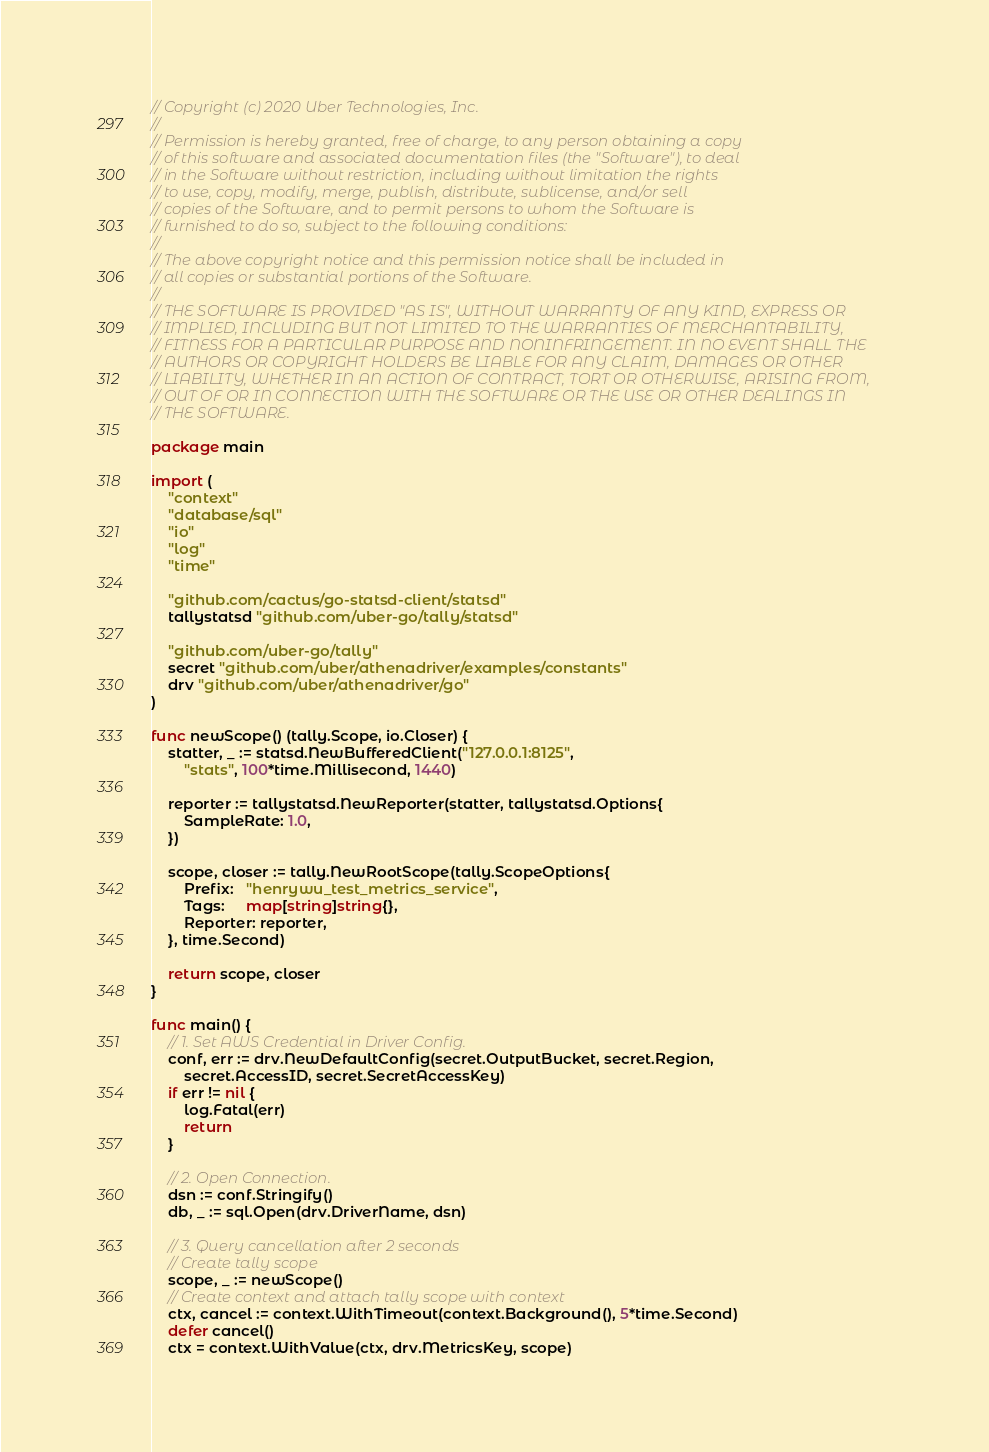<code> <loc_0><loc_0><loc_500><loc_500><_Go_>// Copyright (c) 2020 Uber Technologies, Inc.
//
// Permission is hereby granted, free of charge, to any person obtaining a copy
// of this software and associated documentation files (the "Software"), to deal
// in the Software without restriction, including without limitation the rights
// to use, copy, modify, merge, publish, distribute, sublicense, and/or sell
// copies of the Software, and to permit persons to whom the Software is
// furnished to do so, subject to the following conditions:
//
// The above copyright notice and this permission notice shall be included in
// all copies or substantial portions of the Software.
//
// THE SOFTWARE IS PROVIDED "AS IS", WITHOUT WARRANTY OF ANY KIND, EXPRESS OR
// IMPLIED, INCLUDING BUT NOT LIMITED TO THE WARRANTIES OF MERCHANTABILITY,
// FITNESS FOR A PARTICULAR PURPOSE AND NONINFRINGEMENT. IN NO EVENT SHALL THE
// AUTHORS OR COPYRIGHT HOLDERS BE LIABLE FOR ANY CLAIM, DAMAGES OR OTHER
// LIABILITY, WHETHER IN AN ACTION OF CONTRACT, TORT OR OTHERWISE, ARISING FROM,
// OUT OF OR IN CONNECTION WITH THE SOFTWARE OR THE USE OR OTHER DEALINGS IN
// THE SOFTWARE.

package main

import (
	"context"
	"database/sql"
	"io"
	"log"
	"time"

	"github.com/cactus/go-statsd-client/statsd"
	tallystatsd "github.com/uber-go/tally/statsd"

	"github.com/uber-go/tally"
	secret "github.com/uber/athenadriver/examples/constants"
	drv "github.com/uber/athenadriver/go"
)

func newScope() (tally.Scope, io.Closer) {
	statter, _ := statsd.NewBufferedClient("127.0.0.1:8125",
		"stats", 100*time.Millisecond, 1440)

	reporter := tallystatsd.NewReporter(statter, tallystatsd.Options{
		SampleRate: 1.0,
	})

	scope, closer := tally.NewRootScope(tally.ScopeOptions{
		Prefix:   "henrywu_test_metrics_service",
		Tags:     map[string]string{},
		Reporter: reporter,
	}, time.Second)

	return scope, closer
}

func main() {
	// 1. Set AWS Credential in Driver Config.
	conf, err := drv.NewDefaultConfig(secret.OutputBucket, secret.Region,
		secret.AccessID, secret.SecretAccessKey)
	if err != nil {
		log.Fatal(err)
		return
	}

	// 2. Open Connection.
	dsn := conf.Stringify()
	db, _ := sql.Open(drv.DriverName, dsn)

	// 3. Query cancellation after 2 seconds
	// Create tally scope
	scope, _ := newScope()
	// Create context and attach tally scope with context
	ctx, cancel := context.WithTimeout(context.Background(), 5*time.Second)
	defer cancel()
	ctx = context.WithValue(ctx, drv.MetricsKey, scope)</code> 